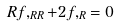Convert formula to latex. <formula><loc_0><loc_0><loc_500><loc_500>R f , _ { R R } + 2 f , _ { R } = 0</formula> 